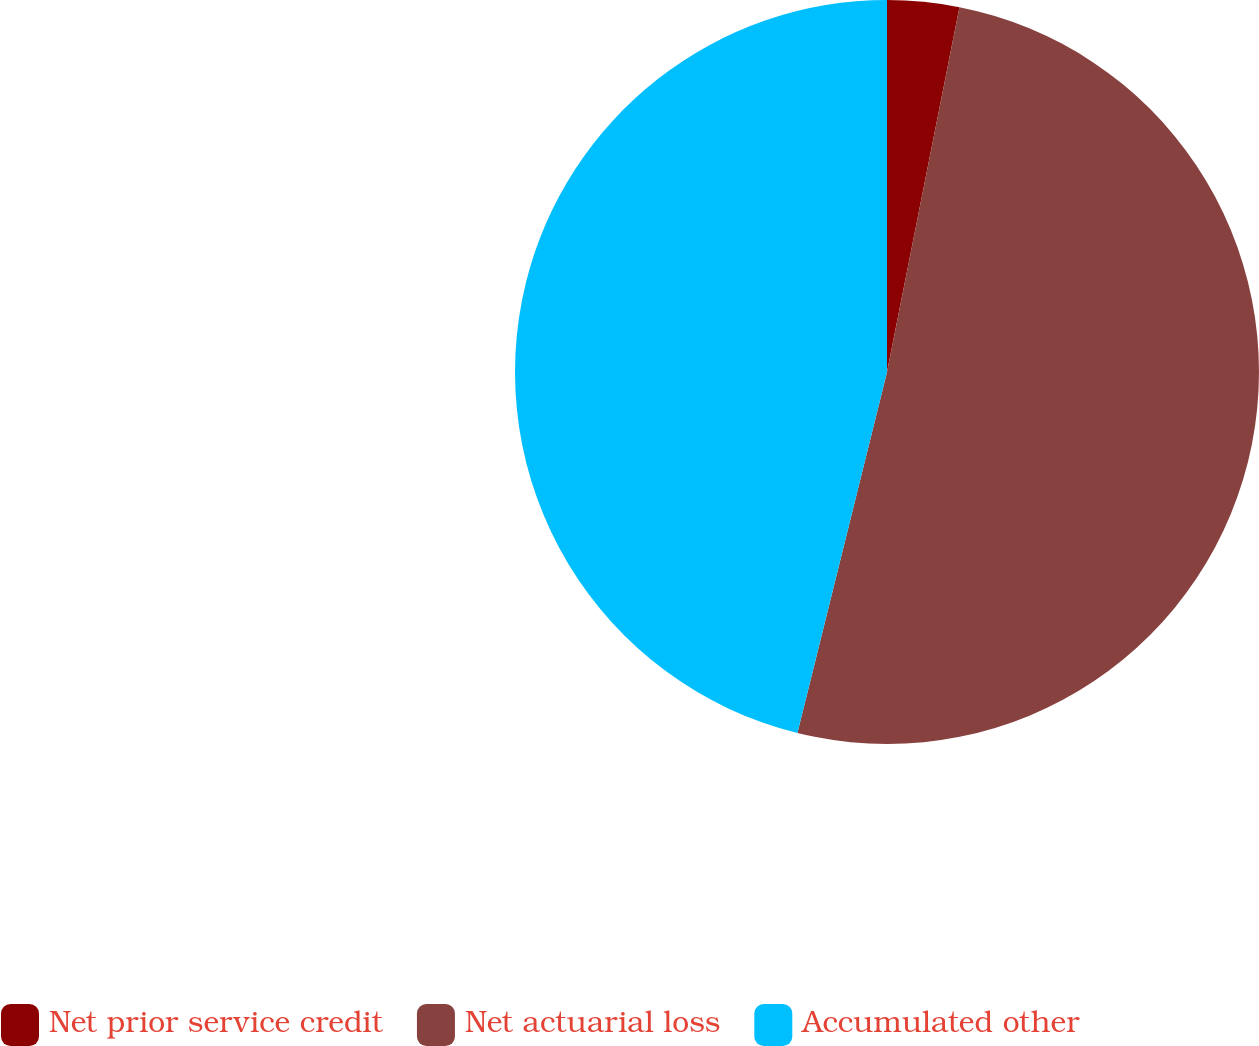<chart> <loc_0><loc_0><loc_500><loc_500><pie_chart><fcel>Net prior service credit<fcel>Net actuarial loss<fcel>Accumulated other<nl><fcel>3.12%<fcel>50.75%<fcel>46.13%<nl></chart> 